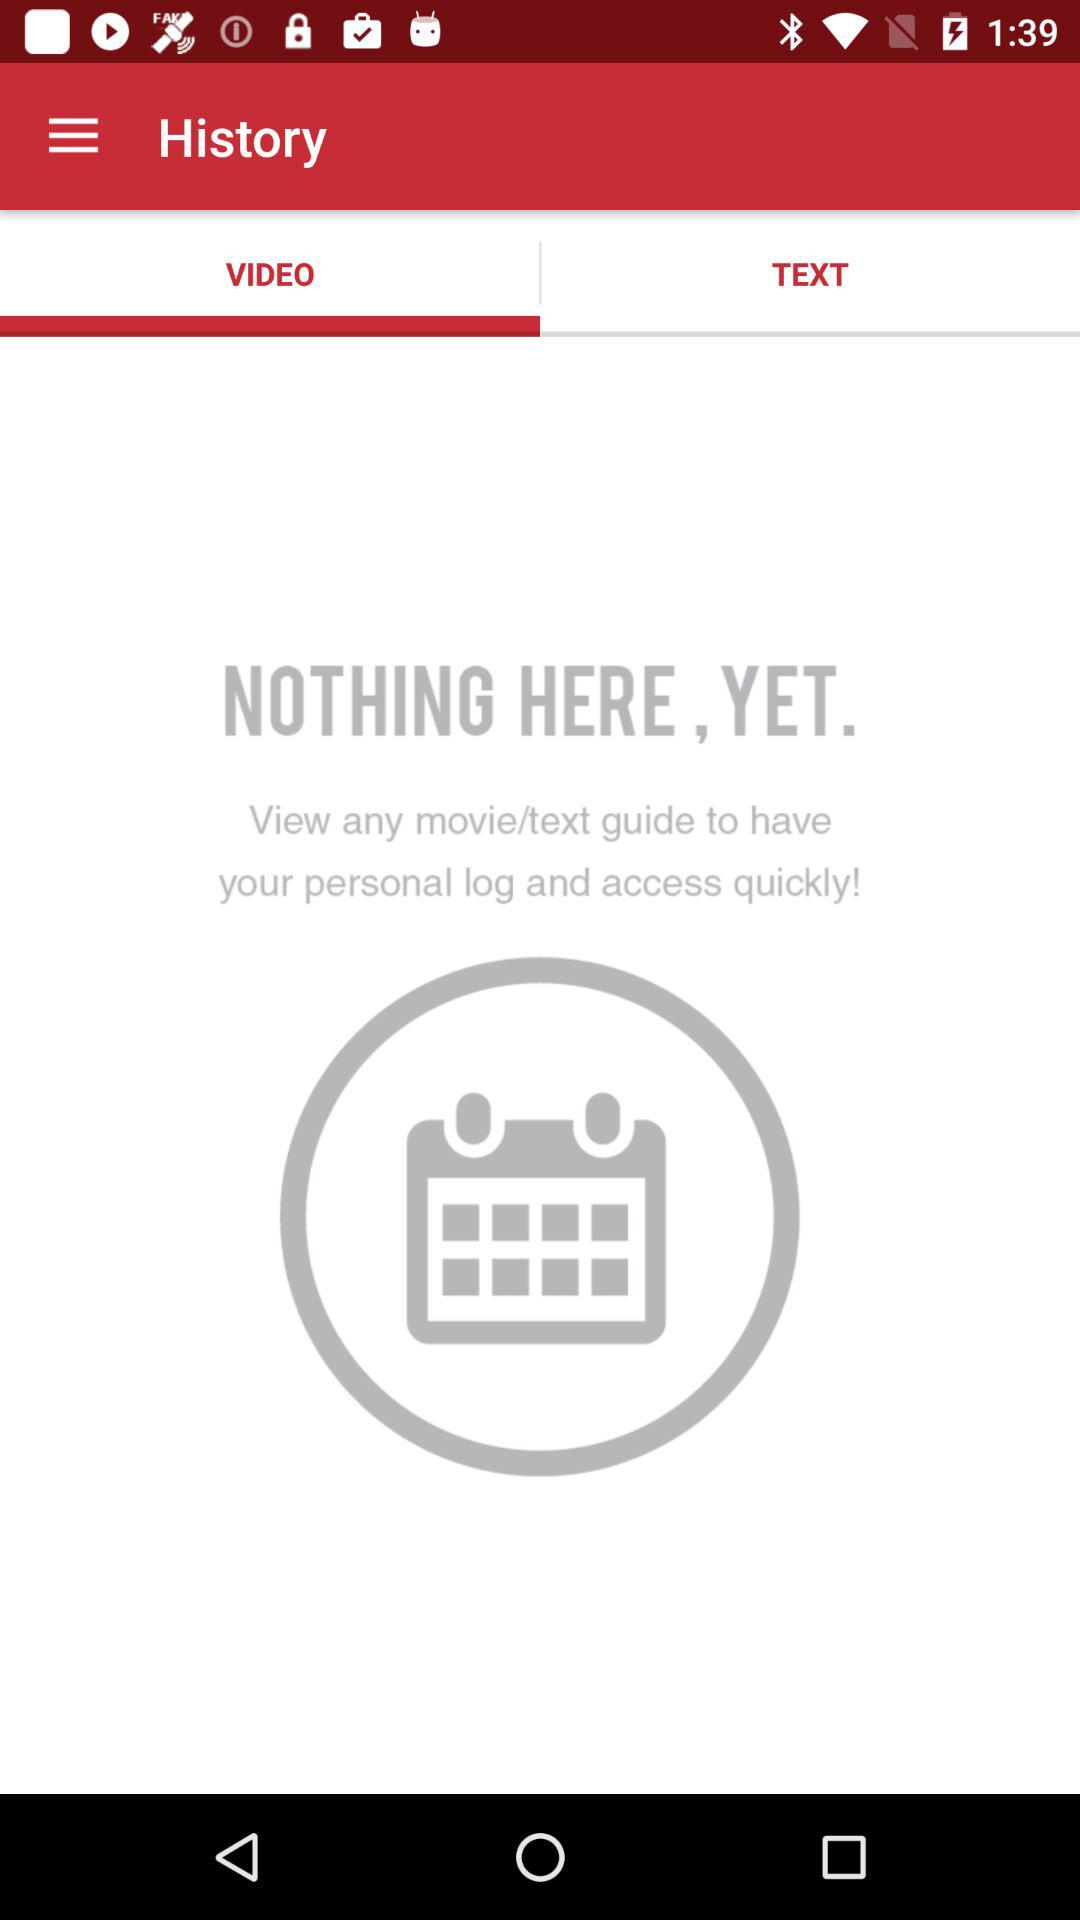What is in the "TEXT" history?
When the provided information is insufficient, respond with <no answer>. <no answer> 